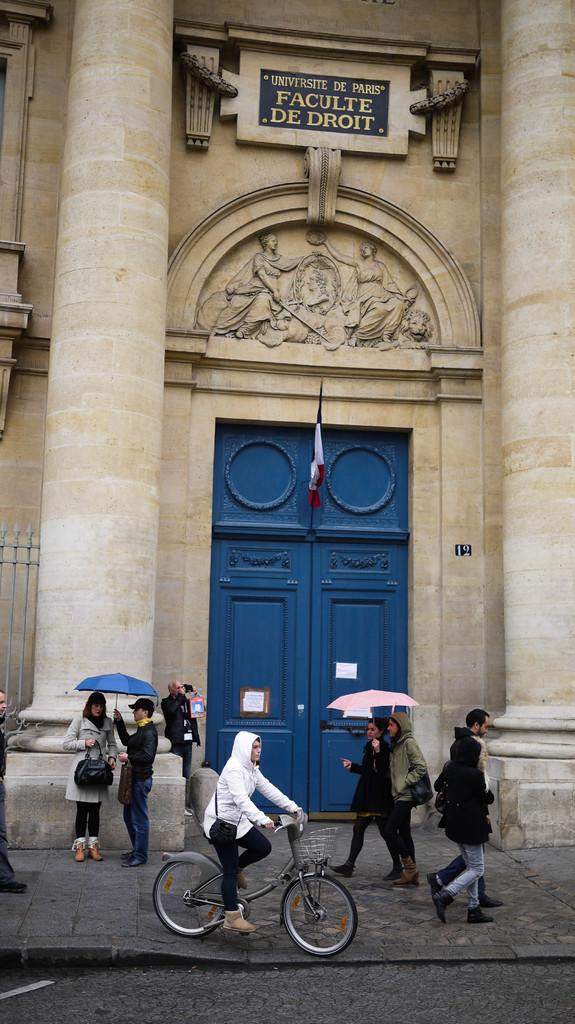What is the main subject in the foreground of the image? There is a man riding a cycle in the foreground of the image. What can be seen happening in the background of the image? There are people moving on the side path in the background of the image. What structure is visible in the background of the image? The entrance of a building is visible in the background of the image. How many boats are visible in the image? There are no boats present in the image. What type of yoke is being used by the man riding the cycle? The man riding the cycle is not using a yoke; he is riding a bicycle, which typically does not require a yoke. 